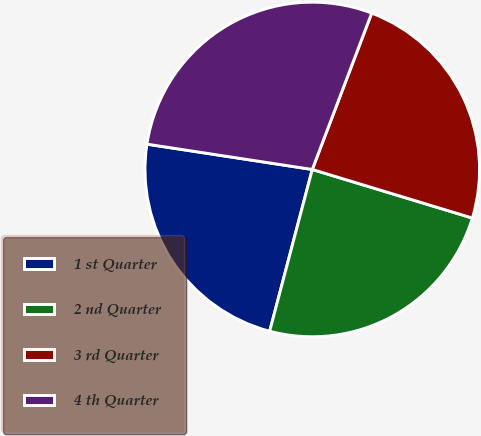Convert chart to OTSL. <chart><loc_0><loc_0><loc_500><loc_500><pie_chart><fcel>1 st Quarter<fcel>2 nd Quarter<fcel>3 rd Quarter<fcel>4 th Quarter<nl><fcel>23.32%<fcel>24.41%<fcel>23.91%<fcel>28.36%<nl></chart> 